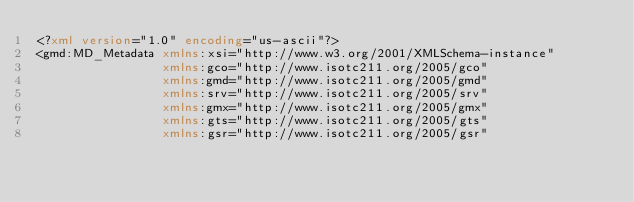Convert code to text. <code><loc_0><loc_0><loc_500><loc_500><_XML_><?xml version="1.0" encoding="us-ascii"?>
<gmd:MD_Metadata xmlns:xsi="http://www.w3.org/2001/XMLSchema-instance"
                 xmlns:gco="http://www.isotc211.org/2005/gco"
                 xmlns:gmd="http://www.isotc211.org/2005/gmd"
                 xmlns:srv="http://www.isotc211.org/2005/srv"
                 xmlns:gmx="http://www.isotc211.org/2005/gmx"
                 xmlns:gts="http://www.isotc211.org/2005/gts"
                 xmlns:gsr="http://www.isotc211.org/2005/gsr"</code> 